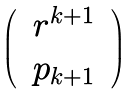Convert formula to latex. <formula><loc_0><loc_0><loc_500><loc_500>\begin{pmatrix} & r ^ { k + 1 } & \\ & p _ { k + 1 } & \end{pmatrix}</formula> 